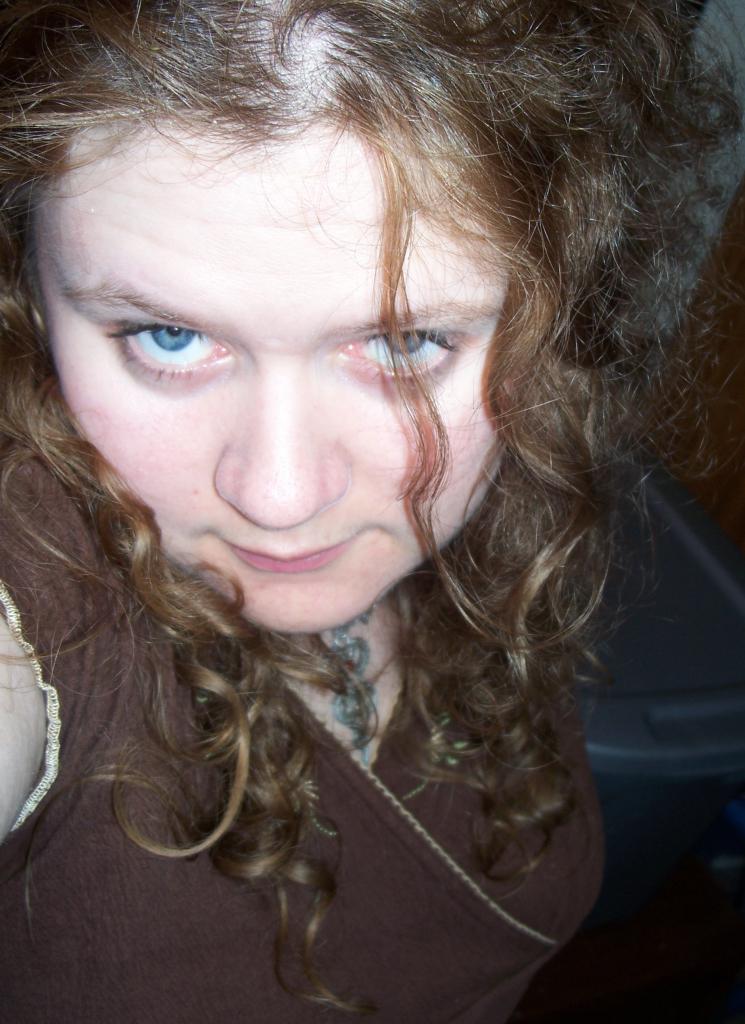Describe this image in one or two sentences. This picture shows a woman. she wore a brown dress and we see a plastic box on the side. 